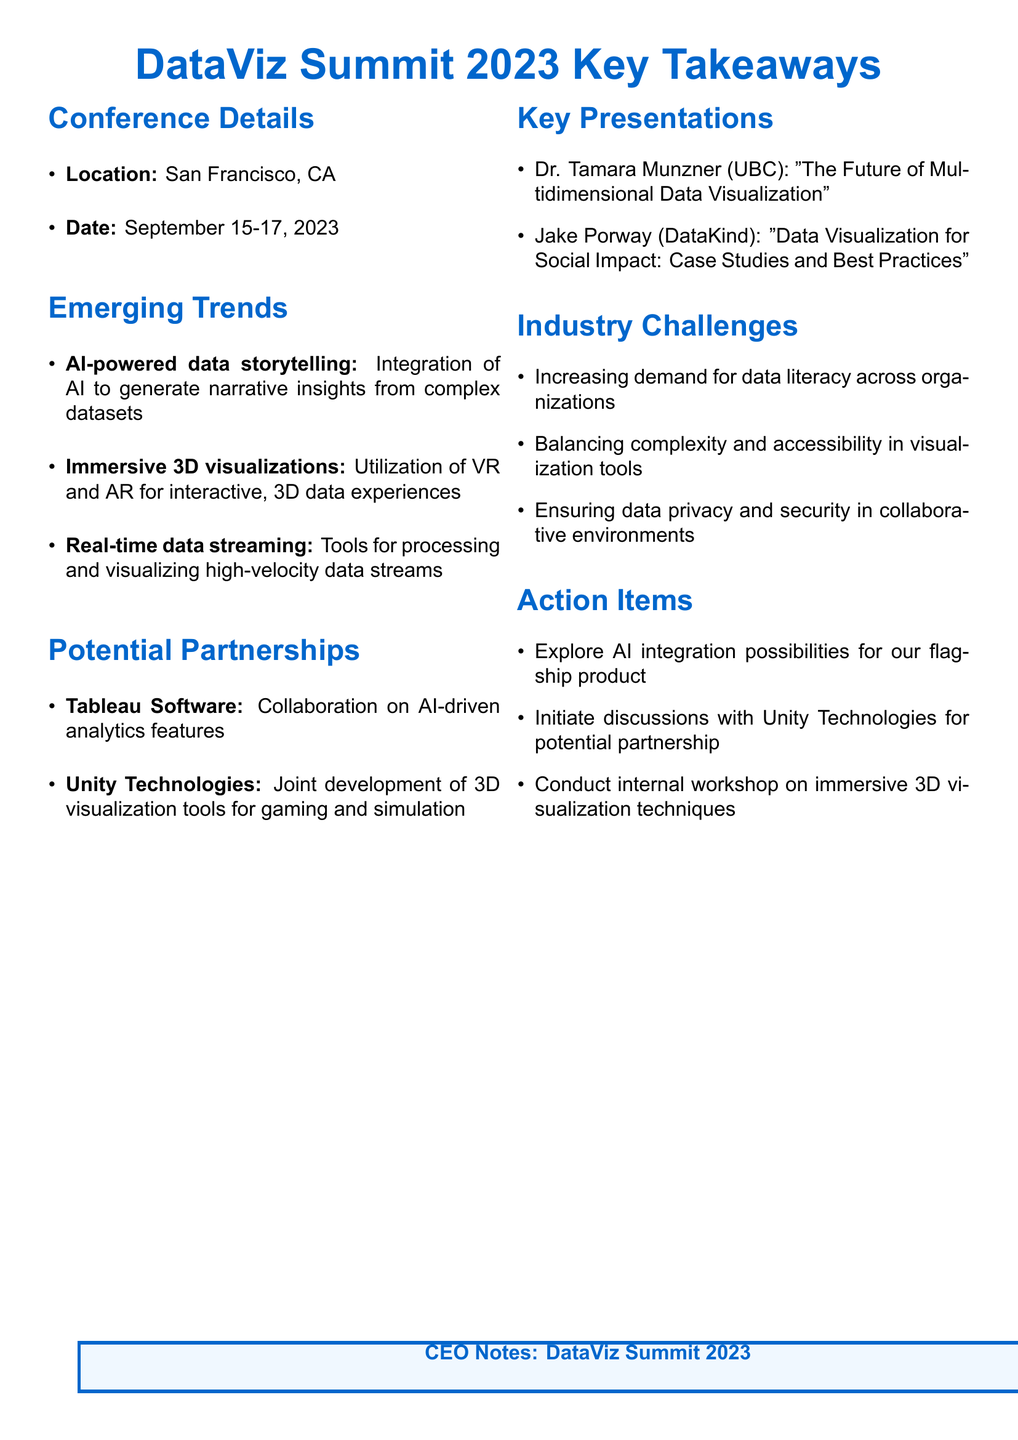What is the name of the conference? The document states that the conference is called "DataViz Summit 2023."
Answer: DataViz Summit 2023 Where was the conference held? The location of the conference is specified in the document as San Francisco, CA.
Answer: San Francisco, CA What is one of the emerging trends discussed? The document mentions several emerging trends, including AI-powered data storytelling, which is specifically highlighted.
Answer: AI-powered data storytelling Who gave a key presentation on multidimensional data visualization? The document lists Dr. Tamara Munzner from the University of British Columbia as the speaker on this topic.
Answer: Dr. Tamara Munzner What is a potential partnership opportunity mentioned in the notes? The document lists Tableau Software as a potential partner for collaboration on AI-driven analytics features.
Answer: Tableau Software What is one of the industry challenges noted? One of the challenges mentioned is the increasing demand for data literacy across organizations.
Answer: Increasing demand for data literacy How many days did the conference last? The conference took place over three days, from September 15 to September 17, 2023.
Answer: Three days What action item is suggested regarding partnership discussions? The document mentions initiating discussions with Unity Technologies for a potential partnership as an action item.
Answer: Discussions with Unity Technologies What technology is associated with immersive 3D visualizations? The document states that VR and AR technologies are utilized for immersive 3D visualizations.
Answer: VR and AR technologies 